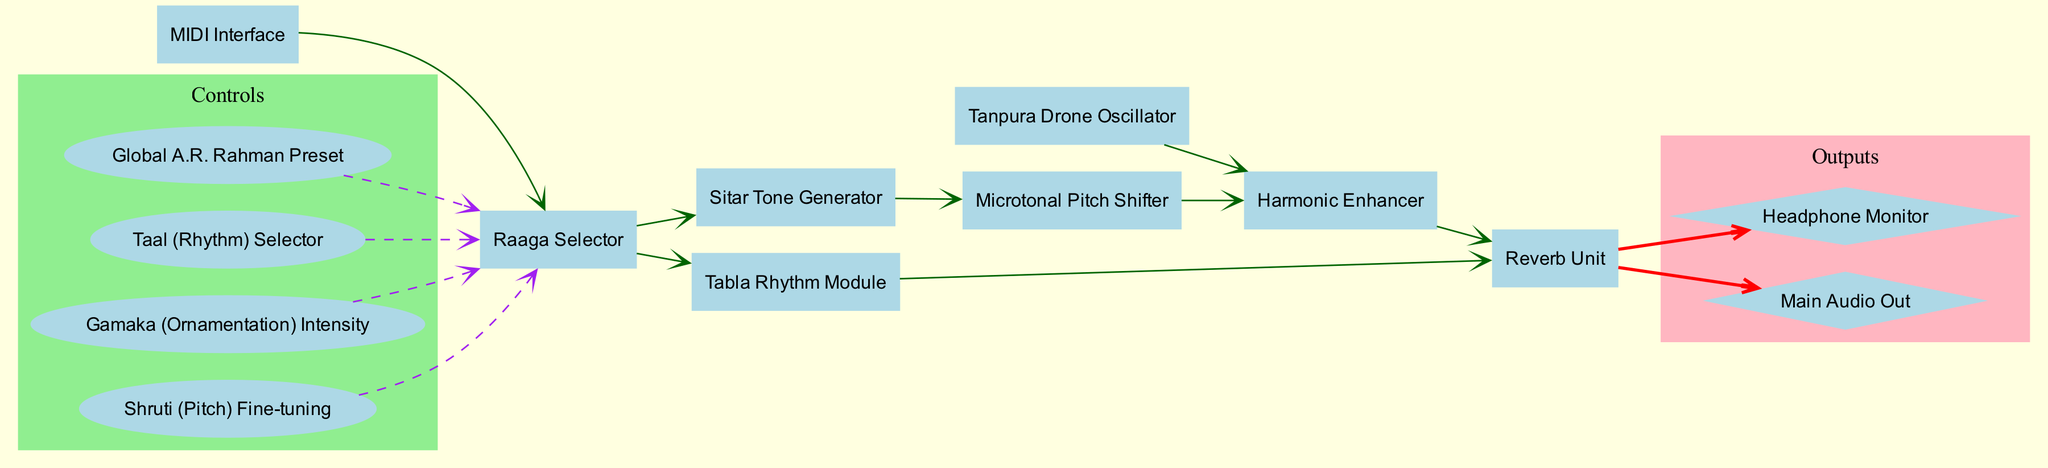What is the number of components in the diagram? The diagram lists 8 components including the Raaga Selector, Sitar Tone Generator, Tabla Rhythm Module, Tanpura Drone Oscillator, Microtonal Pitch Shifter, MIDI Interface, Harmonic Enhancer, and Reverb Unit. By counting them, we find there are 8 distinct components.
Answer: 8 Which module does the Raaga Selector connect to? The Raaga Selector connects to two modules as depicted in the connections: the Sitar Tone Generator and the Tabla Rhythm Module. Therefore, it connects to these two specific modules for producing sound.
Answer: Sitar Tone Generator and Tabla Rhythm Module How many outputs can be seen in the diagram? The diagram specifies 2 outputs, which are the Main Audio Out and the Headphone Monitor. These are clearly labeled in the outputs section of the diagram.
Answer: 2 What type of unit is directly connected to the Harmonic Enhancer? According to the connections, the Harmonic Enhancer receives input from two modules: the Tanpura Drone Oscillator and the Microtonal Pitch Shifter. Therefore, the type of units directly connected to it include these two.
Answer: Tanpura Drone Oscillator and Microtonal Pitch Shifter What color are the control nodes in the diagram? The control nodes are surrounded by a light green background in the controls cluster, indicating they belong to the controls section. Each control node, which includes Shruti, Gamaka, Taal selector, and Global A.R. Rahman Preset, is marked in this specific color.
Answer: Light green 